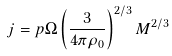Convert formula to latex. <formula><loc_0><loc_0><loc_500><loc_500>j = p \Omega \left ( \frac { 3 } { 4 \pi { \rho } _ { 0 } } \right ) ^ { 2 / 3 } M ^ { 2 / 3 }</formula> 